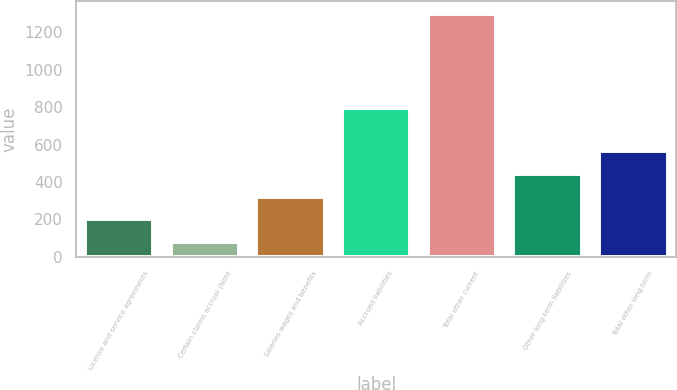Convert chart. <chart><loc_0><loc_0><loc_500><loc_500><bar_chart><fcel>License and service agreements<fcel>Certain claims accrual (Note<fcel>Salaries wages and benefits<fcel>Accrued liabilities<fcel>Total other current<fcel>Other long-term liabilities<fcel>Total other long-term<nl><fcel>200.18<fcel>78<fcel>322.36<fcel>795.2<fcel>1299.8<fcel>444.54<fcel>566.72<nl></chart> 